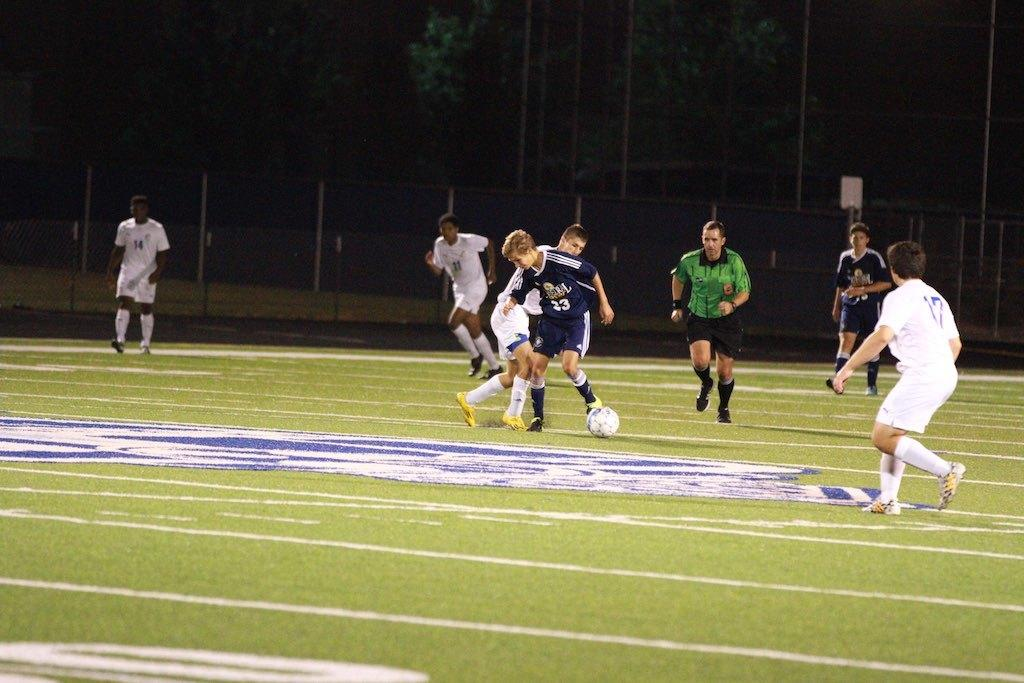What activity are the men in the image engaged in? The men are playing football in the image. Where is the football game taking place? The football game is taking place on a green field. What can be seen in the background of the image? There are trees visible around the field. What type of toy can be seen in the cave in the image? There is no cave or toy present in the image; it features a group of men playing football on a green field with trees in the background. 